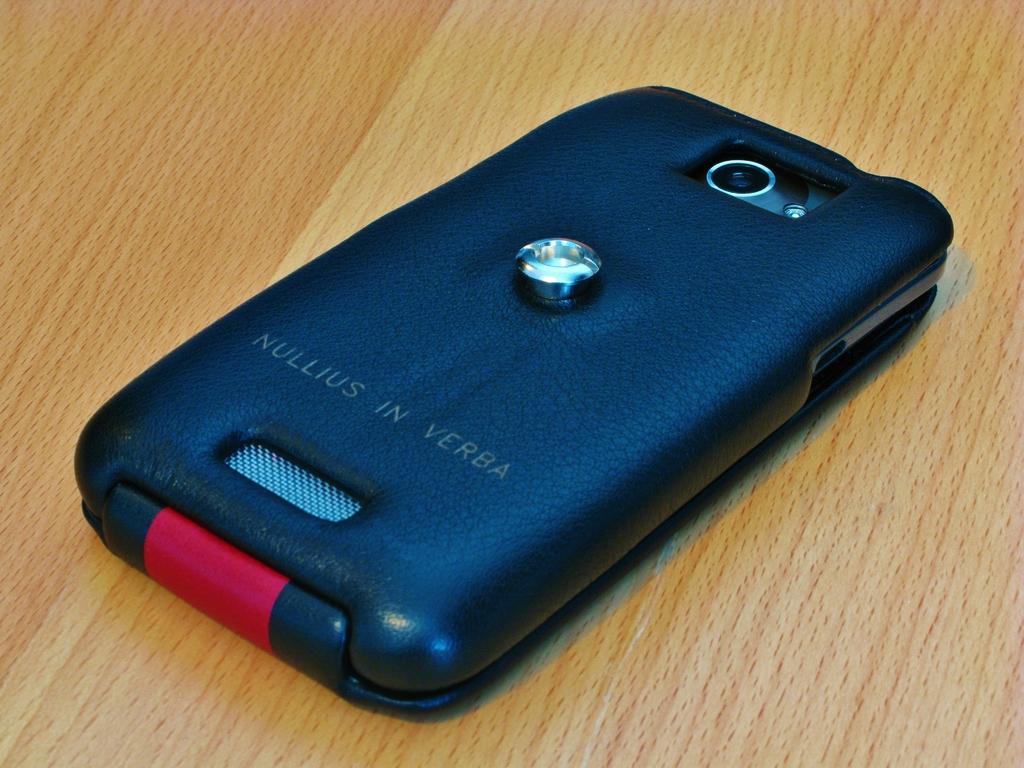What is in verba?
Provide a short and direct response. Nullius. 